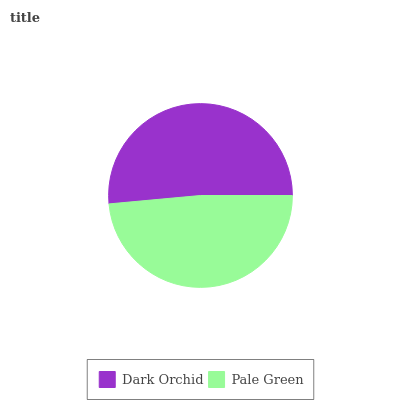Is Pale Green the minimum?
Answer yes or no. Yes. Is Dark Orchid the maximum?
Answer yes or no. Yes. Is Pale Green the maximum?
Answer yes or no. No. Is Dark Orchid greater than Pale Green?
Answer yes or no. Yes. Is Pale Green less than Dark Orchid?
Answer yes or no. Yes. Is Pale Green greater than Dark Orchid?
Answer yes or no. No. Is Dark Orchid less than Pale Green?
Answer yes or no. No. Is Dark Orchid the high median?
Answer yes or no. Yes. Is Pale Green the low median?
Answer yes or no. Yes. Is Pale Green the high median?
Answer yes or no. No. Is Dark Orchid the low median?
Answer yes or no. No. 